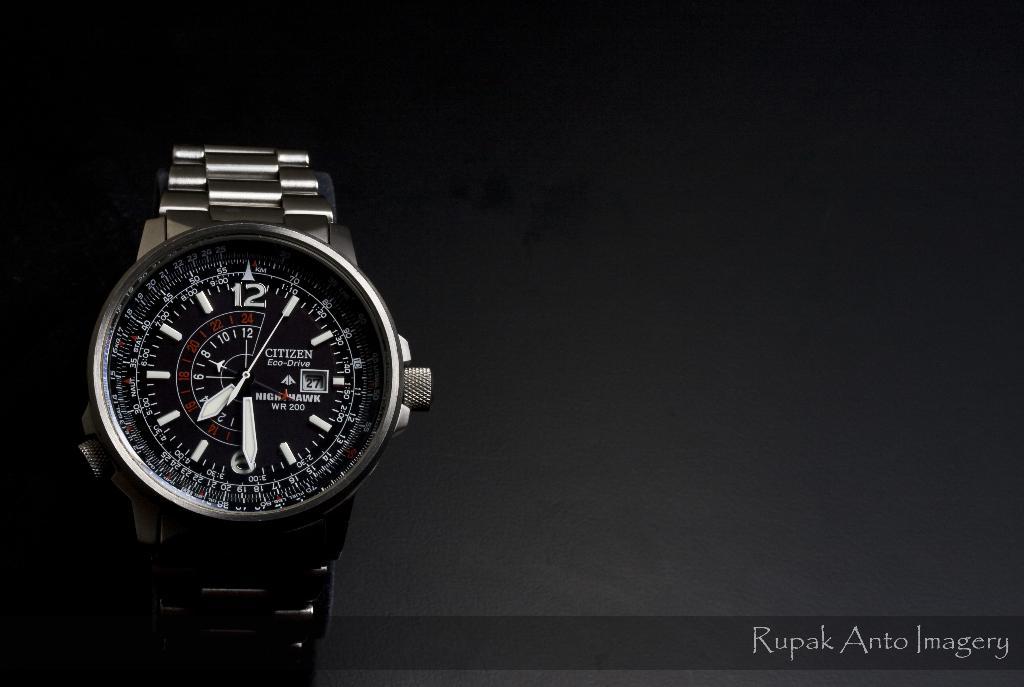What brand of watch is this?
Your answer should be compact. Citizen. What is the time shown by the watch?
Keep it short and to the point. 7:29. 